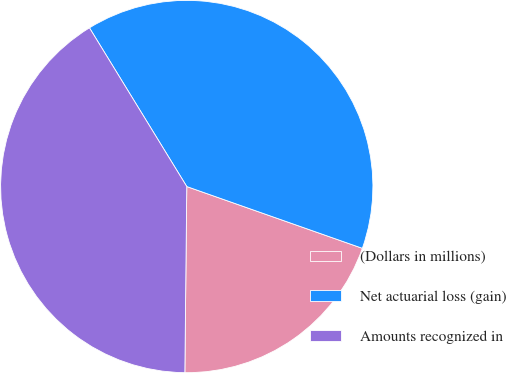Convert chart. <chart><loc_0><loc_0><loc_500><loc_500><pie_chart><fcel>(Dollars in millions)<fcel>Net actuarial loss (gain)<fcel>Amounts recognized in<nl><fcel>19.78%<fcel>39.14%<fcel>41.08%<nl></chart> 